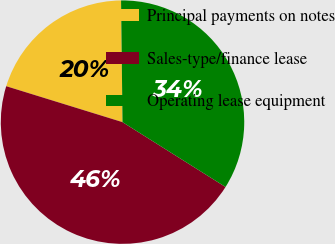Convert chart to OTSL. <chart><loc_0><loc_0><loc_500><loc_500><pie_chart><fcel>Principal payments on notes<fcel>Sales-type/finance lease<fcel>Operating lease equipment<nl><fcel>20.04%<fcel>45.83%<fcel>34.13%<nl></chart> 